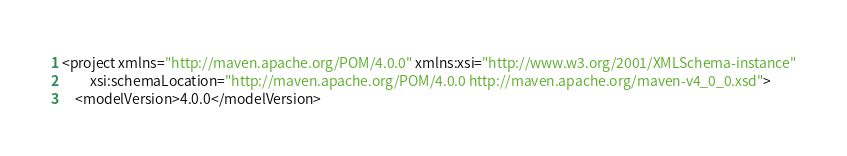<code> <loc_0><loc_0><loc_500><loc_500><_XML_><project xmlns="http://maven.apache.org/POM/4.0.0" xmlns:xsi="http://www.w3.org/2001/XMLSchema-instance"
         xsi:schemaLocation="http://maven.apache.org/POM/4.0.0 http://maven.apache.org/maven-v4_0_0.xsd">
  	<modelVersion>4.0.0</modelVersion></code> 